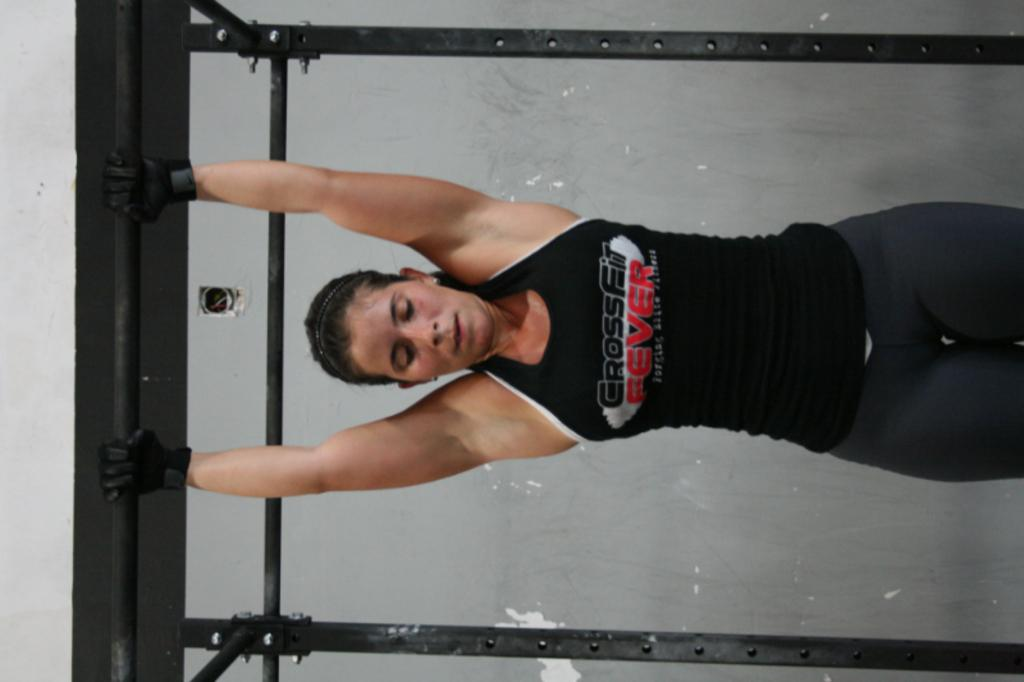Who or what is the main subject in the image? There is a person in the image. What is the person wearing? The person is wearing a black dress. What is the person holding in the image? The person is holding a pole. What can be seen in the background of the image? The background of the image includes a gray wall. What type of bun is the person eating in the image? There is no bun present in the image; the person is holding a pole. What kind of work is the person doing in the image? The image does not provide any information about the person's work or occupation. 